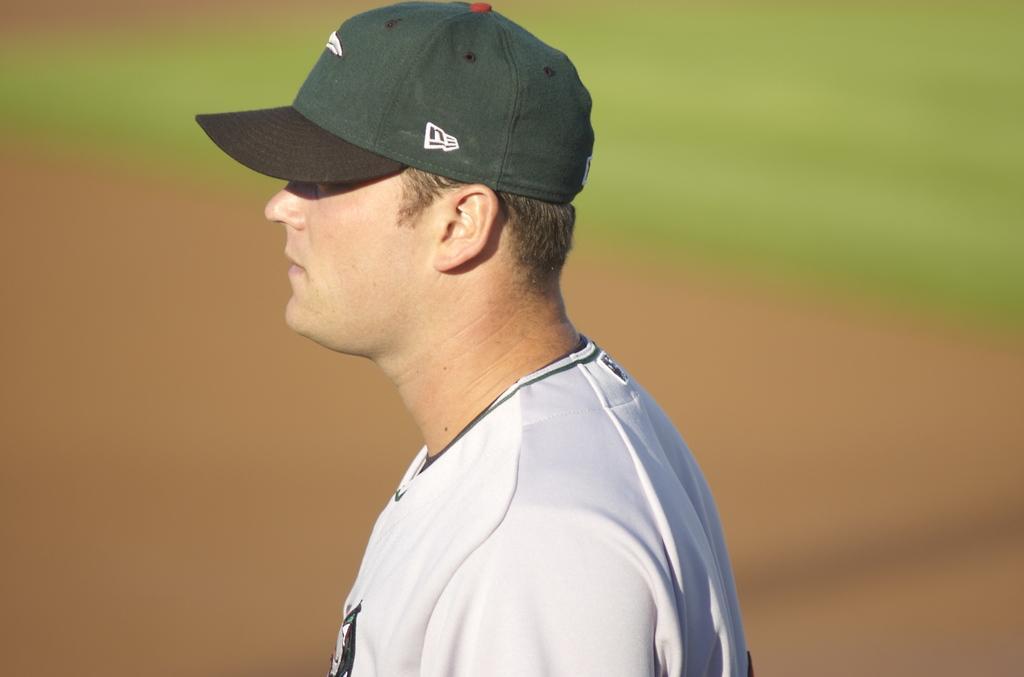Can you describe this image briefly? In this image I can see a man, I can see he is wearing white colour dress and a green colour cap. I can also see green and brown colour in background. I can see this image is blurry from background. 